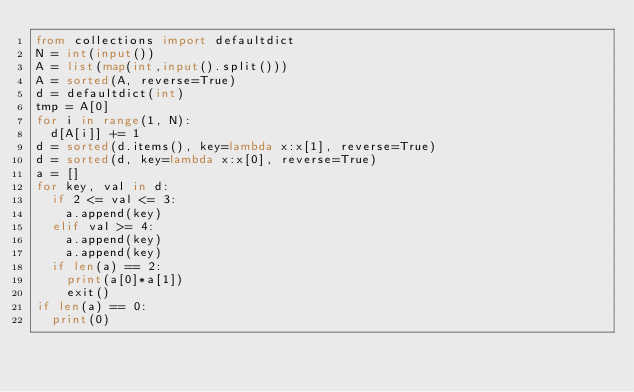Convert code to text. <code><loc_0><loc_0><loc_500><loc_500><_Python_>from collections import defaultdict
N = int(input())
A = list(map(int,input().split()))
A = sorted(A, reverse=True)
d = defaultdict(int)
tmp = A[0]
for i in range(1, N):
  d[A[i]] += 1
d = sorted(d.items(), key=lambda x:x[1], reverse=True)
d = sorted(d, key=lambda x:x[0], reverse=True)
a = []
for key, val in d:
  if 2 <= val <= 3:
    a.append(key)
  elif val >= 4:
    a.append(key)
    a.append(key)
  if len(a) == 2:
    print(a[0]*a[1])
    exit()
if len(a) == 0:
  print(0)</code> 